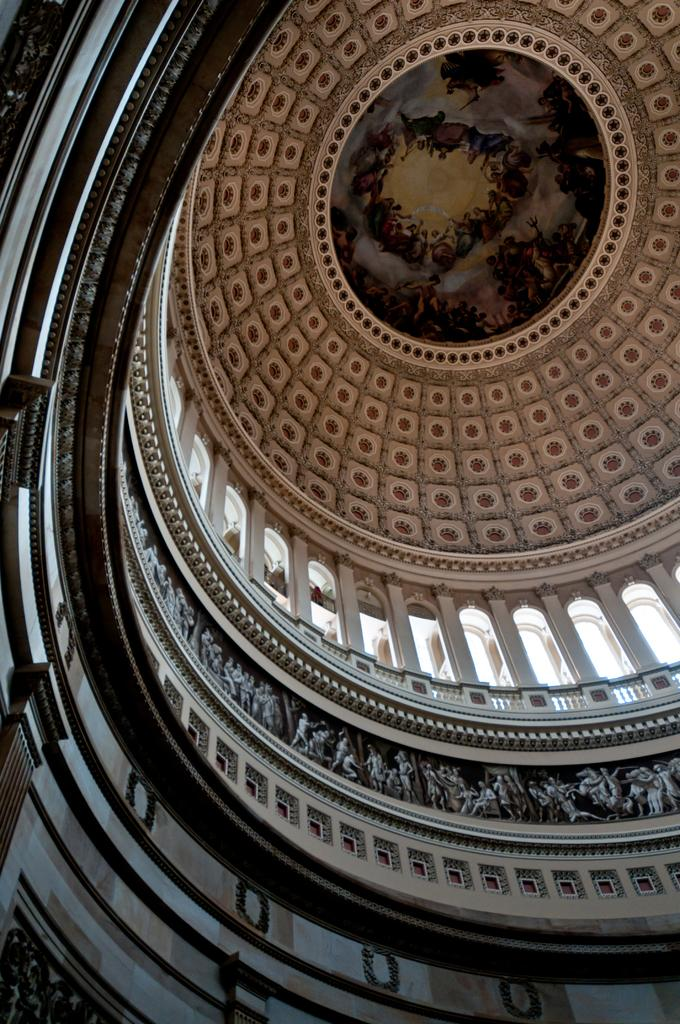What type of location is depicted in the image? The image is an inside view of a building. What architectural features can be seen in the image? There are walls, pillars, and railings in the image. What design elements are present in the image? There is a design and carvings in the image. What is the size of the nose in the image? There is no nose present in the image; it is an inside view of a building with architectural features and design elements. 